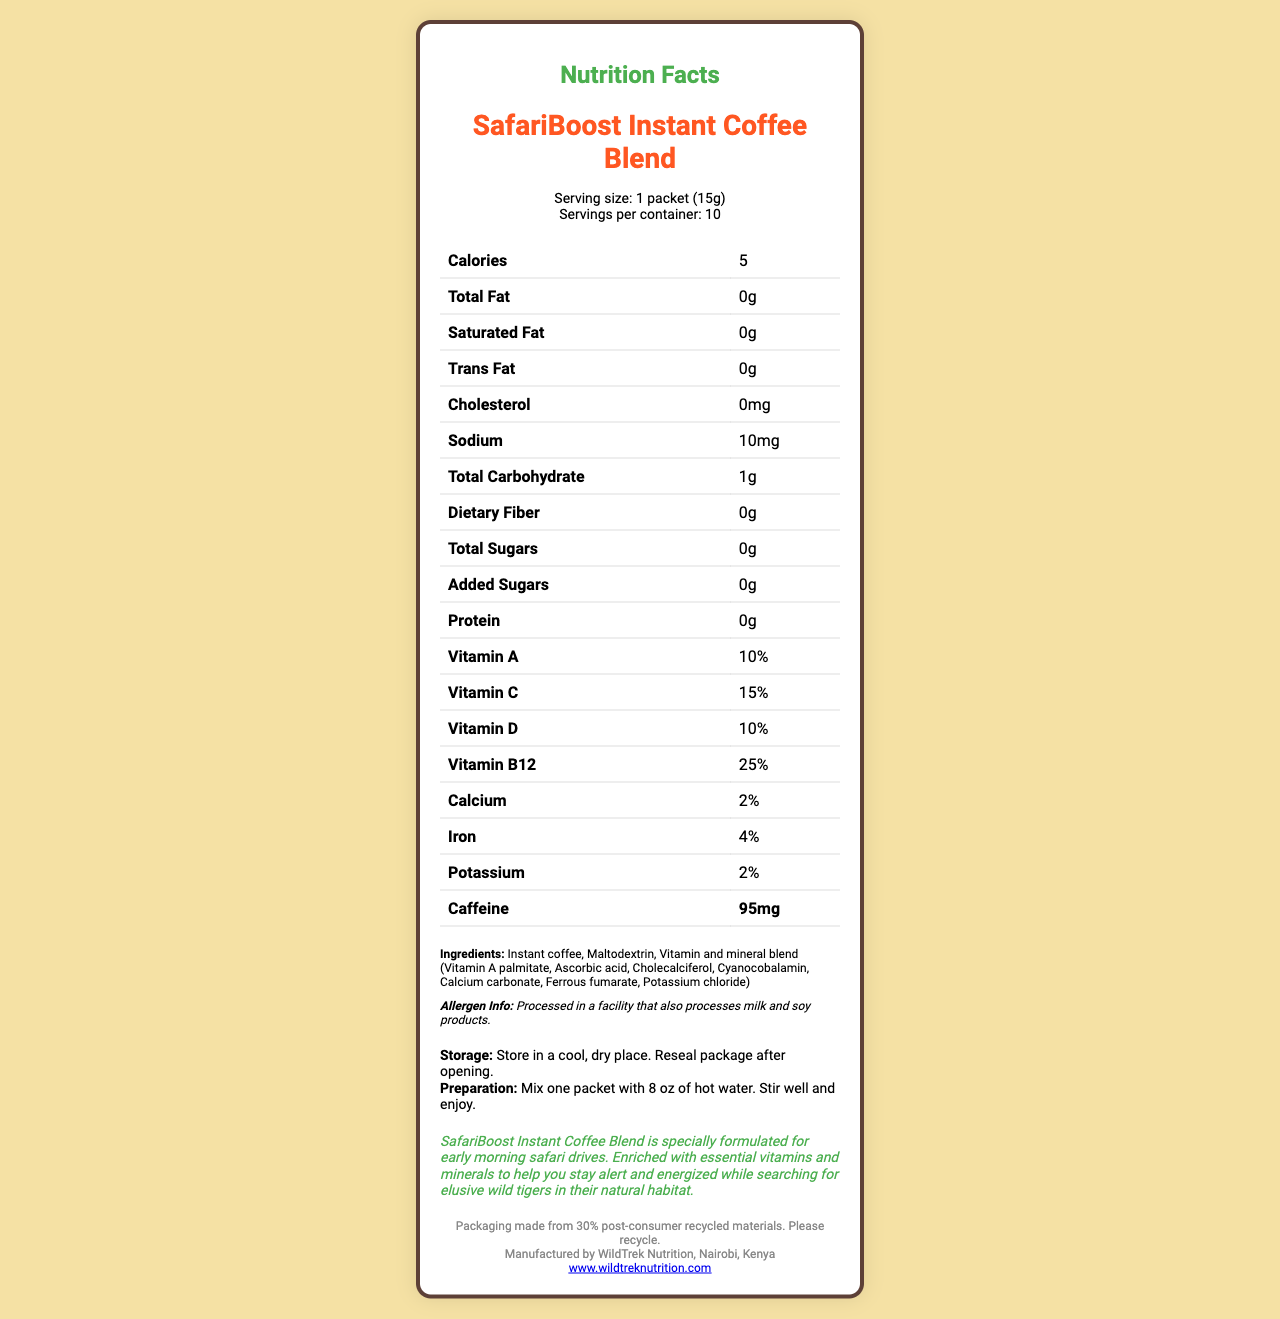how many servings are in one container? According to the document, there are 10 servings per container.
Answer: 10 how much caffeine does one serving contain? The document mentions that each serving contains 95mg of caffeine.
Answer: 95mg what is the percentage of daily value for Vitamin B12? The Nutrition Facts list Vitamin B12 as providing 25% of the daily value.
Answer: 25% what ingredient is listed first? The first ingredient listed is "Instant coffee," indicating it is the main component.
Answer: Instant coffee what is the total carbohydrate content per serving? The total carbohydrate content for each serving is 1 gram.
Answer: 1g which vitamin has the highest percentage of the daily value? A. Vitamin A B. Vitamin C C. Vitamin D D. Vitamin B12 The document states that Vitamin B12 has the highest percentage of the daily value at 25%.
Answer: D which nutrient has the lowest daily value percentage? A. Calcium B. Iron C. Potassium D. Vitamin C Calcium has the lowest daily value percentage at 2%.
Answer: A is there any added sugar in this product? The document indicates that the total added sugars per serving are 0g.
Answer: No does this product contain any dietary fiber? The dietary fiber content per serving is listed as 0g.
Answer: No where is this product manufactured? The document states that the product is manufactured by WildTrek Nutrition in Nairobi, Kenya.
Answer: Nairobi, Kenya summarize the main intent of this document. The document provides nutritional facts, ingredient information, preparation and storage instructions, and a product description highlighting its benefits for safari drives.
Answer: SafariBoost Instant Coffee Blend is a fortified instant coffee product designed for early morning safari drives. It contains essential vitamins and minerals to keep you alert and energized, with 95mg of caffeine per serving. Each container has 10 servings, and the product is manufactured in Nairobi, Kenya. can this document provide information on how much this product costs? The document does not include any pricing details, so the cost of the product cannot be determined from the provided visual information.
Answer: Not enough information 